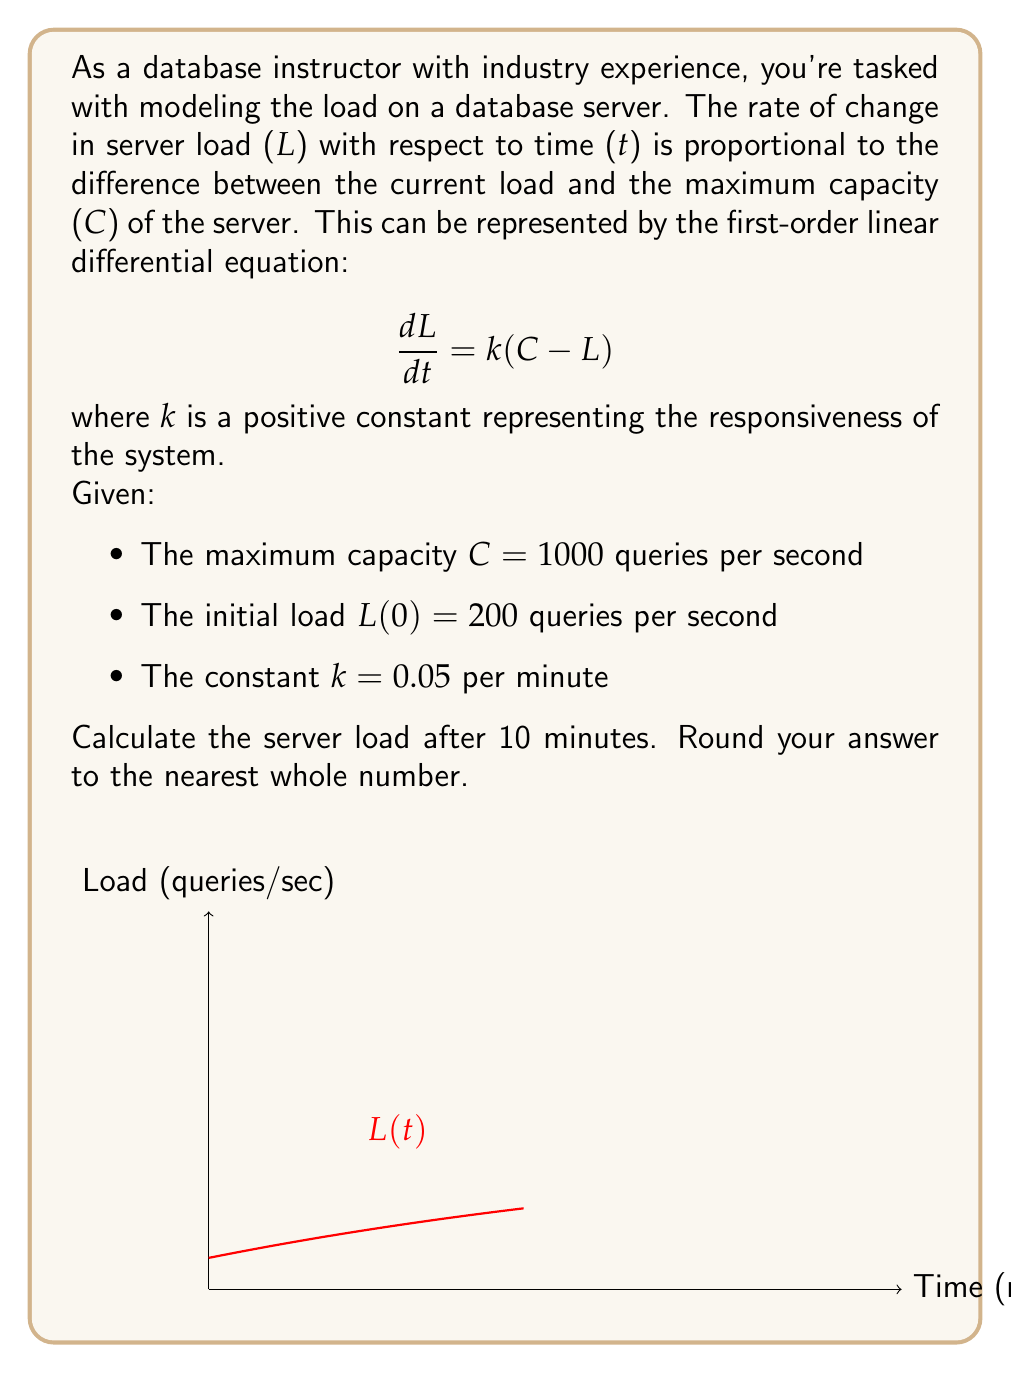Give your solution to this math problem. Let's solve this step-by-step:

1) The general solution for this type of differential equation is:
   $$L(t) = C + (L_0 - C)e^{-kt}$$
   where $L_0$ is the initial load.

2) Plug in the given values:
   C = 1000, $L_0$ = 200, k = 0.05

3) Substitute these into the general solution:
   $$L(t) = 1000 + (200 - 1000)e^{-0.05t}$$

4) Simplify:
   $$L(t) = 1000 - 800e^{-0.05t}$$

5) To find the load after 10 minutes, substitute t = 10:
   $$L(10) = 1000 - 800e^{-0.05(10)}$$

6) Calculate:
   $$L(10) = 1000 - 800e^{-0.5}$$
   $$L(10) = 1000 - 800(0.6065)$$
   $$L(10) = 1000 - 485.2$$
   $$L(10) = 514.8$$

7) Rounding to the nearest whole number:
   L(10) ≈ 515 queries per second
Answer: 515 queries per second 